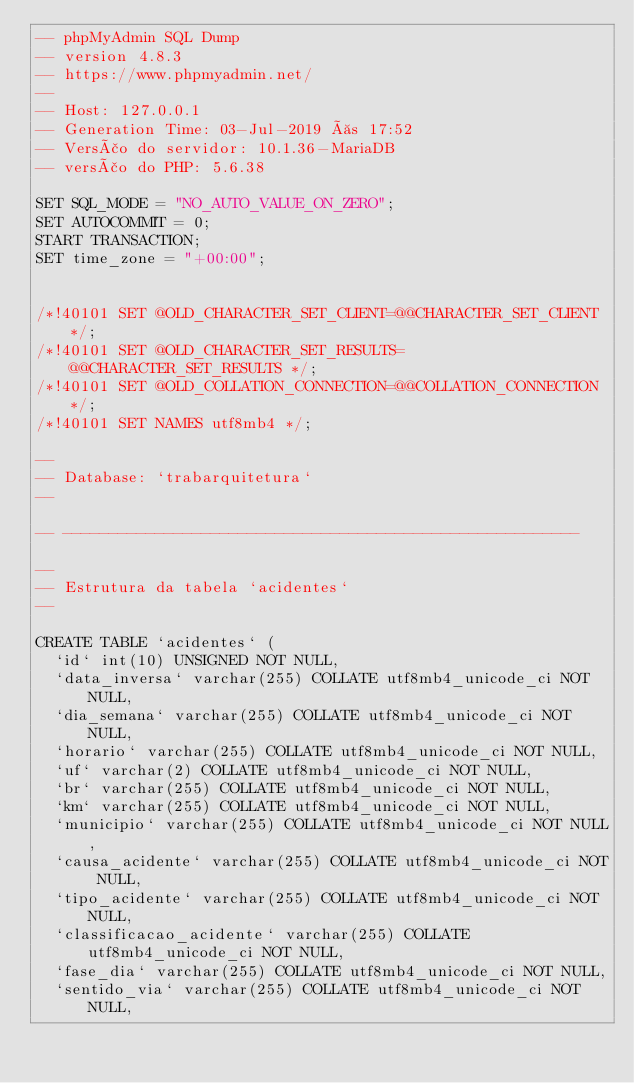<code> <loc_0><loc_0><loc_500><loc_500><_SQL_>-- phpMyAdmin SQL Dump
-- version 4.8.3
-- https://www.phpmyadmin.net/
--
-- Host: 127.0.0.1
-- Generation Time: 03-Jul-2019 às 17:52
-- Versão do servidor: 10.1.36-MariaDB
-- versão do PHP: 5.6.38

SET SQL_MODE = "NO_AUTO_VALUE_ON_ZERO";
SET AUTOCOMMIT = 0;
START TRANSACTION;
SET time_zone = "+00:00";


/*!40101 SET @OLD_CHARACTER_SET_CLIENT=@@CHARACTER_SET_CLIENT */;
/*!40101 SET @OLD_CHARACTER_SET_RESULTS=@@CHARACTER_SET_RESULTS */;
/*!40101 SET @OLD_COLLATION_CONNECTION=@@COLLATION_CONNECTION */;
/*!40101 SET NAMES utf8mb4 */;

--
-- Database: `trabarquitetura`
--

-- --------------------------------------------------------

--
-- Estrutura da tabela `acidentes`
--

CREATE TABLE `acidentes` (
  `id` int(10) UNSIGNED NOT NULL,
  `data_inversa` varchar(255) COLLATE utf8mb4_unicode_ci NOT NULL,
  `dia_semana` varchar(255) COLLATE utf8mb4_unicode_ci NOT NULL,
  `horario` varchar(255) COLLATE utf8mb4_unicode_ci NOT NULL,
  `uf` varchar(2) COLLATE utf8mb4_unicode_ci NOT NULL,
  `br` varchar(255) COLLATE utf8mb4_unicode_ci NOT NULL,
  `km` varchar(255) COLLATE utf8mb4_unicode_ci NOT NULL,
  `municipio` varchar(255) COLLATE utf8mb4_unicode_ci NOT NULL,
  `causa_acidente` varchar(255) COLLATE utf8mb4_unicode_ci NOT NULL,
  `tipo_acidente` varchar(255) COLLATE utf8mb4_unicode_ci NOT NULL,
  `classificacao_acidente` varchar(255) COLLATE utf8mb4_unicode_ci NOT NULL,
  `fase_dia` varchar(255) COLLATE utf8mb4_unicode_ci NOT NULL,
  `sentido_via` varchar(255) COLLATE utf8mb4_unicode_ci NOT NULL,</code> 